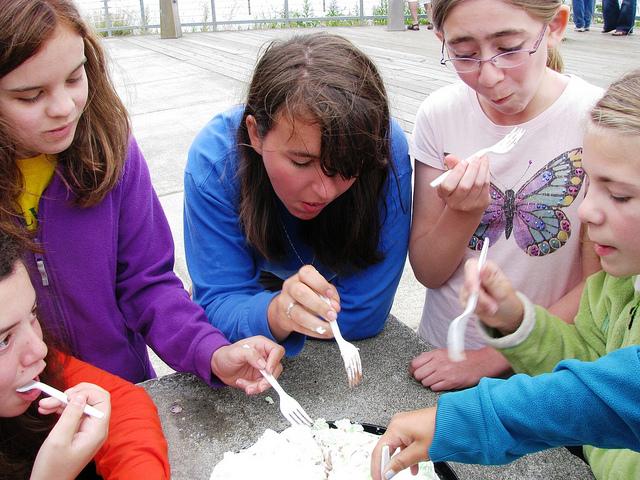What is the mood of the girl in blue?
Answer briefly. Hungry. What are they eating?
Give a very brief answer. Cake. What are their forks made out of?
Quick response, please. Plastic. 